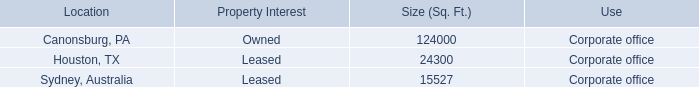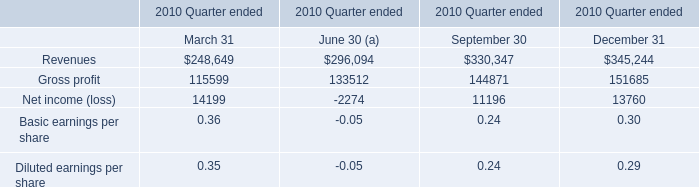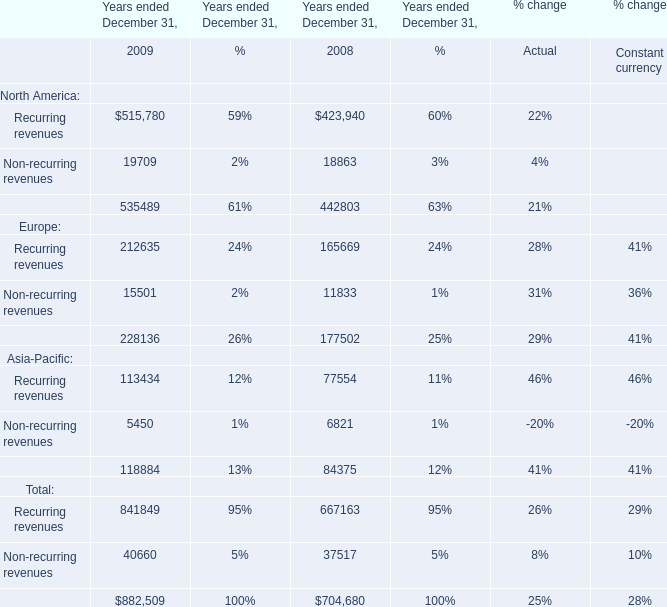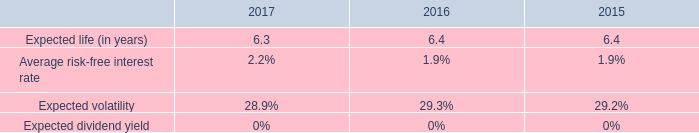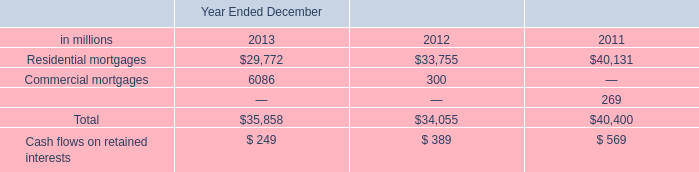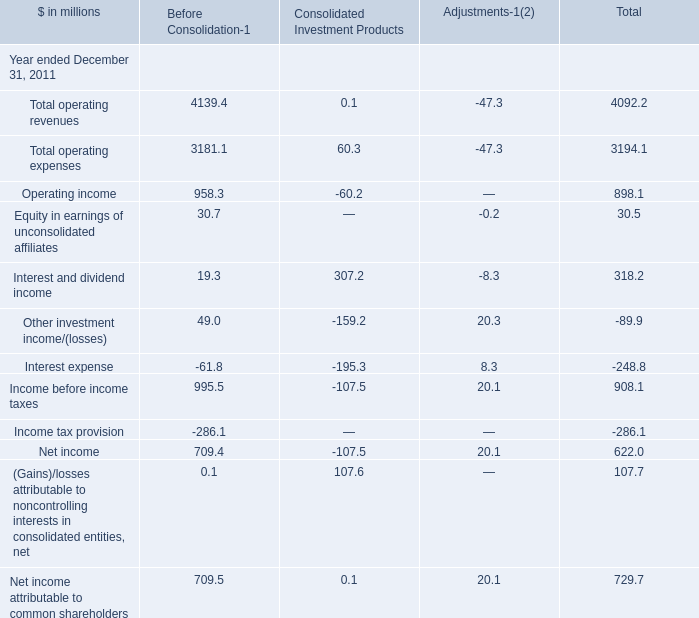What was the average value of the Other investment income/(losses) in the year where (Gains)/losses attributable to noncontrolling interests in consolidated entities, net is positive? 
Computations: (-89.9 / 3)
Answer: -29.96667. 